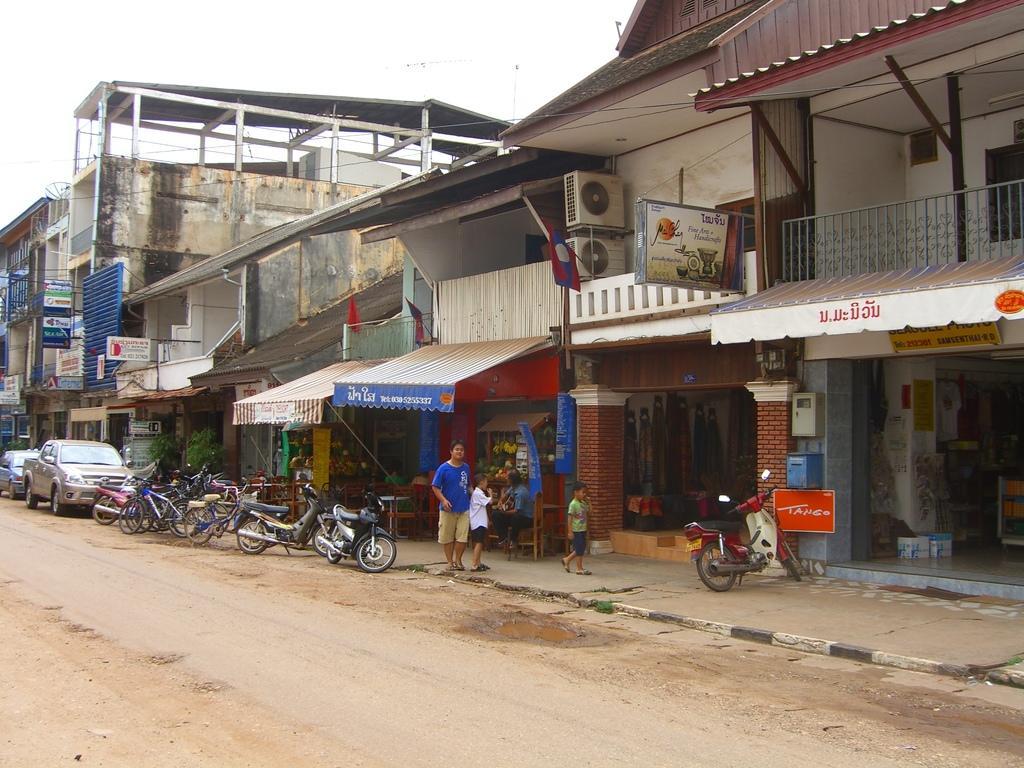Please provide a concise description of this image. In this picture we can see few people, beside them we can find few vehicles, bicycles and hoardings, in the background we can see few buildings and flags. 